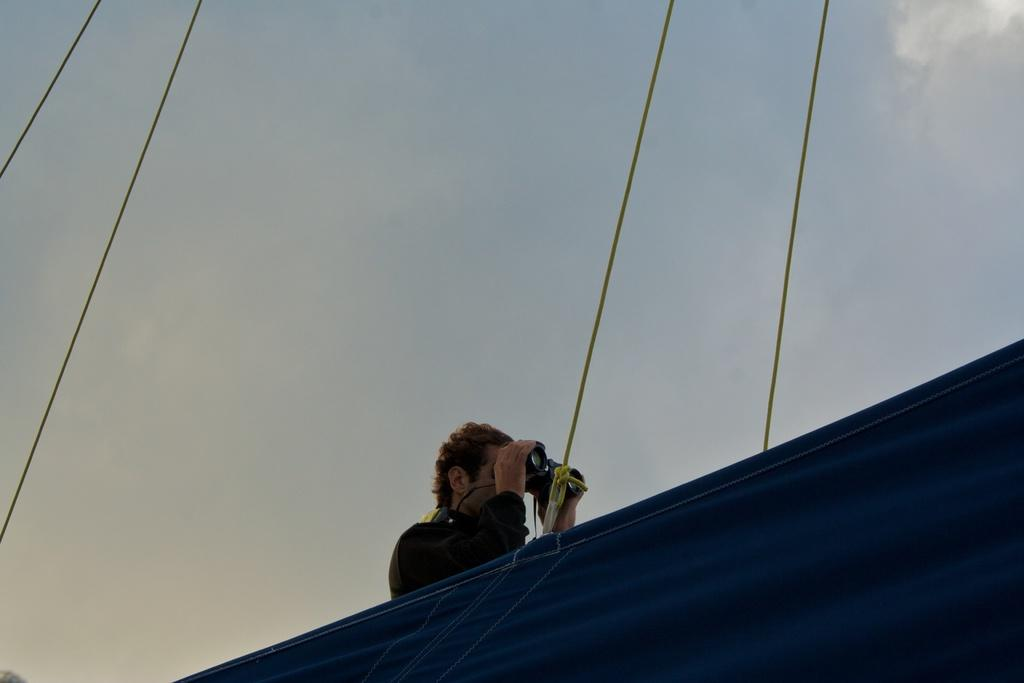What is present in the image? There is a person in the image. What can be seen in the background of the image? There is sky visible in the background of the image, and there are clouds present. What type of vest is the person wearing in the image? There is no vest visible in the image; the person is not wearing one. What time of day is it in the image? The time of day is not mentioned in the image or the provided facts, so it cannot be determined. 